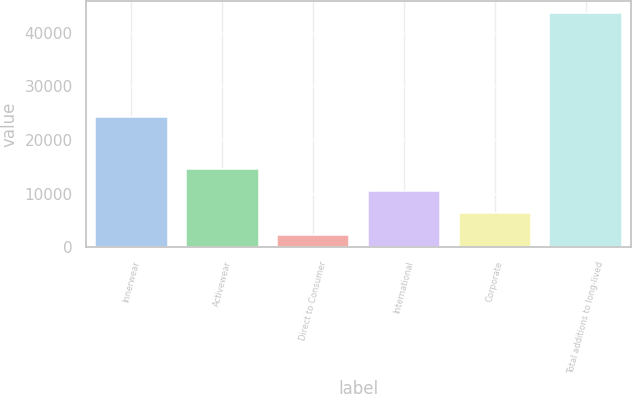Convert chart to OTSL. <chart><loc_0><loc_0><loc_500><loc_500><bar_chart><fcel>Innerwear<fcel>Activewear<fcel>Direct to Consumer<fcel>International<fcel>Corporate<fcel>Total additions to long-lived<nl><fcel>24192<fcel>14619.7<fcel>2188<fcel>10475.8<fcel>6331.9<fcel>43627<nl></chart> 